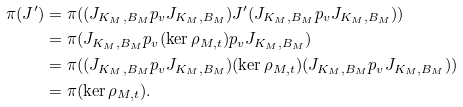<formula> <loc_0><loc_0><loc_500><loc_500>\pi ( J ^ { \prime } ) & = \pi ( ( J _ { K _ { M } , B _ { M } } p _ { v } J _ { K _ { M } , B _ { M } } ) J ^ { \prime } ( J _ { K _ { M } , B _ { M } } p _ { v } J _ { K _ { M } , B _ { M } } ) ) \\ & = \pi ( J _ { K _ { M } , B _ { M } } p _ { v } ( \ker \rho _ { M , t } ) p _ { v } J _ { K _ { M } , B _ { M } } ) \\ & = \pi ( ( J _ { K _ { M } , B _ { M } } p _ { v } J _ { K _ { M } , B _ { M } } ) ( \ker \rho _ { M , t } ) ( J _ { K _ { M } , B _ { M } } p _ { v } J _ { K _ { M } , B _ { M } } ) ) \\ & = \pi ( \ker \rho _ { M , t } ) .</formula> 